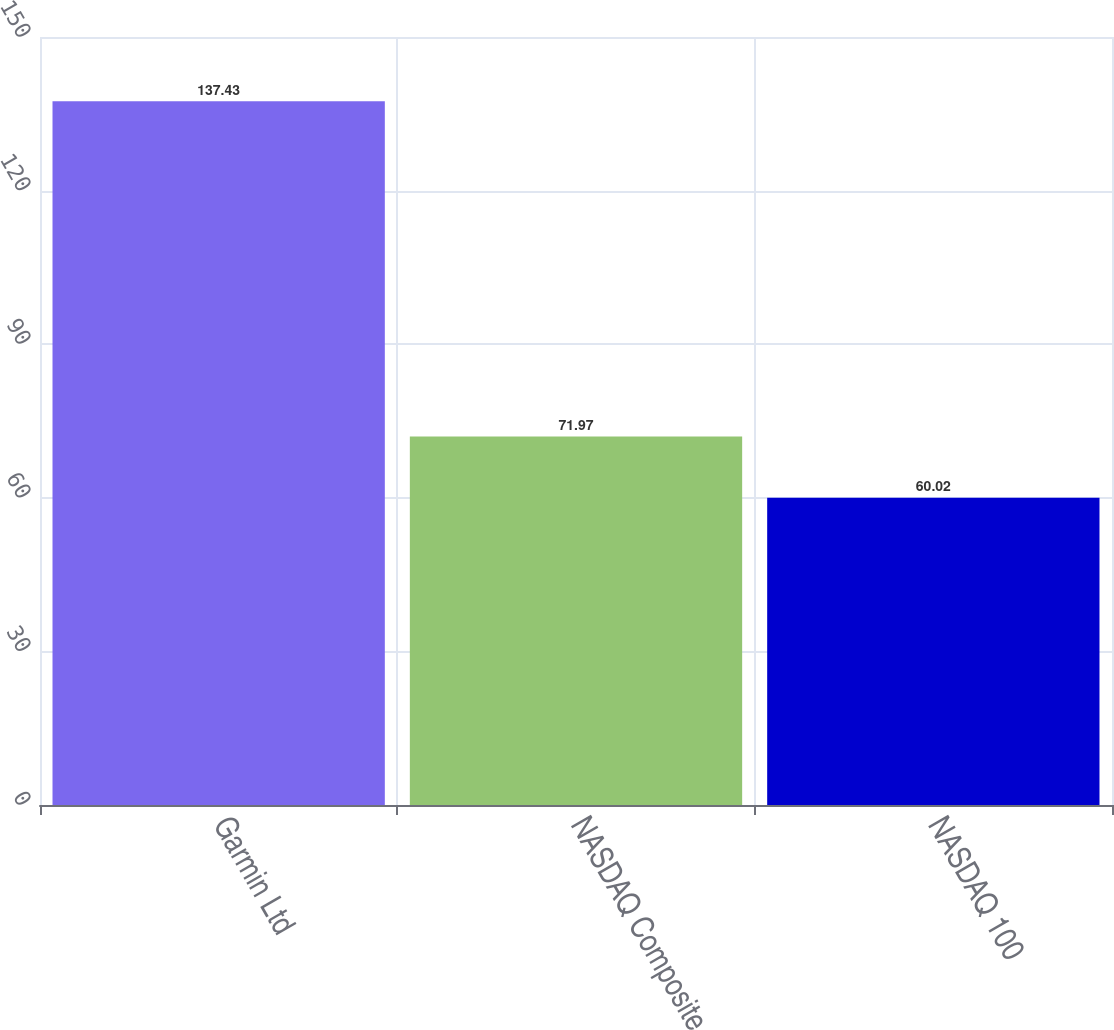<chart> <loc_0><loc_0><loc_500><loc_500><bar_chart><fcel>Garmin Ltd<fcel>NASDAQ Composite<fcel>NASDAQ 100<nl><fcel>137.43<fcel>71.97<fcel>60.02<nl></chart> 